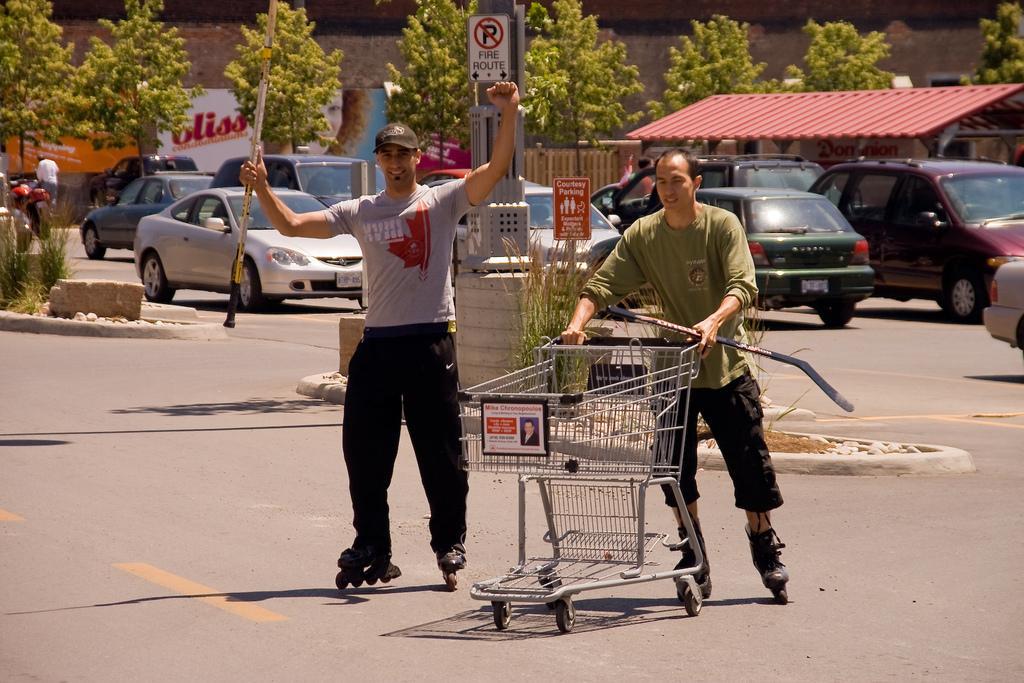Can you describe this image briefly? In this image there are men, they are holding an object, there is road towards the bottom of the image, there are vehicles on the road, there are plants towards the left of the image, there are boards, there is text on the boards, there are trees, there is a roof, at the background of the image there is the wall. 